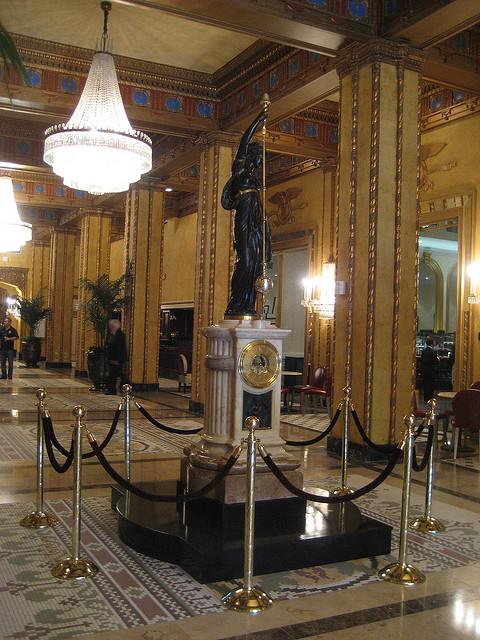Are people allowed to touch the object on the platform?
Concise answer only. No. Are there people in the image?
Give a very brief answer. Yes. Is this a private residence?
Concise answer only. No. 